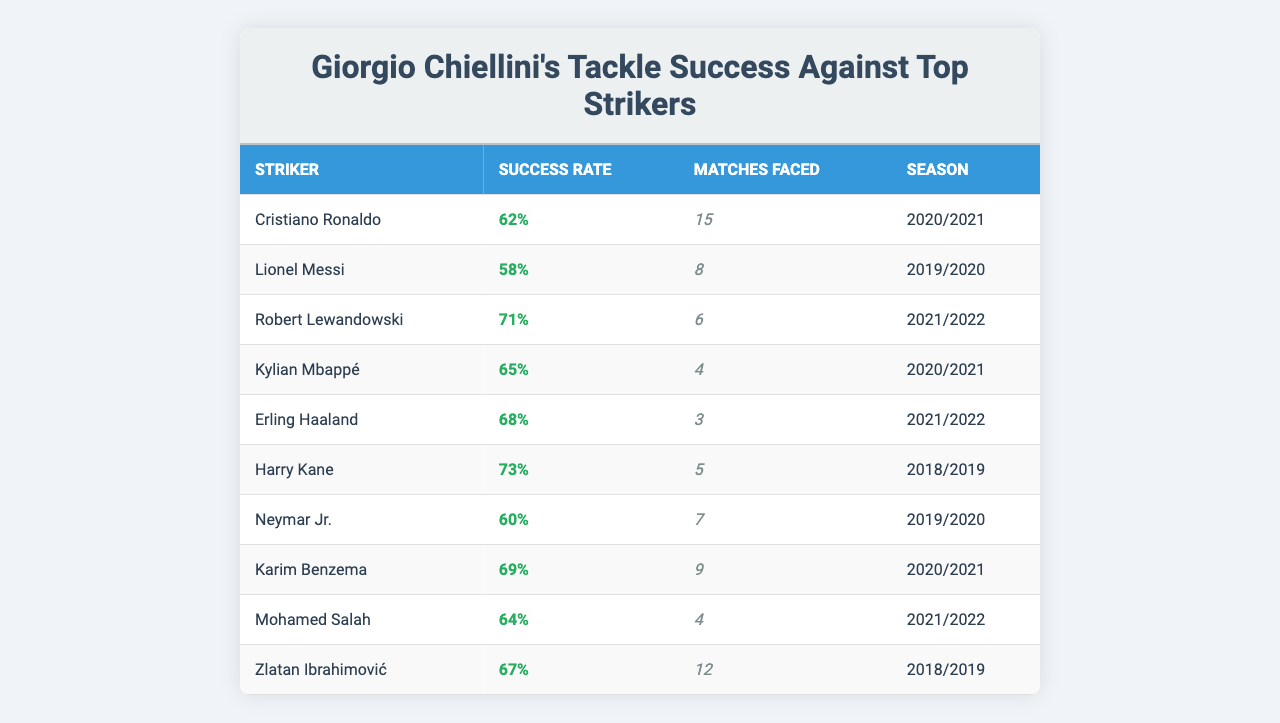What is Giorgio Chiellini's successful tackle percentage against Cristiano Ronaldo? The table shows Chiellini's successful tackle percentage against Ronaldo is listed as 62%.
Answer: 62% How many matches did Chiellini face Lionel Messi? According to the table, Chiellini faced Messi in 8 matches.
Answer: 8 Who had the highest successful tackle percentage against Chiellini? Looking at the table, Harry Kane had the highest successful tackle percentage at 73%.
Answer: 73% What is the average successful tackle percentage against the four strikers with the most matches faced? To find the average, sum the successful tackle percentages of Ronaldo (62%), Messi (58%), Lewandowski (71%), and Kane (73%), which is (62 + 58 + 71 + 73) = 264. Then divide by 4: 264/4 = 66.
Answer: 66% Did Chiellini have a higher successful tackle percentage against Kylian Mbappé or Neymar Jr.? Chiellini had a successful tackle percentage of 65% against Mbappé and 60% against Neymar Jr., indicating he was more successful against Mbappé.
Answer: Yes How many top strikers did Chiellini face in total? The total number of strikers faced is found by counting the data entries in the table, which is 10.
Answer: 10 Was Chiellini more successful in tackling Erling Haaland or Robert Lewandowski? The table shows Chiellini's successful tackle percentage against Haaland was 68%, while against Lewandowski it was 71%, indicating he was more successful against Lewandowski.
Answer: No What is the difference in successful tackle percentages between Mohamed Salah and Zlatan Ibrahimović? Salah's percentage is 64% and Ibrahimović's percentage is 67%. The difference is calculated as 67 - 64 = 3%.
Answer: 3% Which striker had a successful tackle percentage lower than the average of 66%? The successful tackle percentages below 66% are Messi (58%), Neymar (60%), and Ronaldo (62%). Each is less than the average.
Answer: Messi, Neymar, Ronaldo How many successful tackles did Chiellini achieve against Harry Kane in the given season? The data does not provide the exact number of successful tackles, only the percentage. Thus, it cannot be determined from the table.
Answer: Cannot be determined 